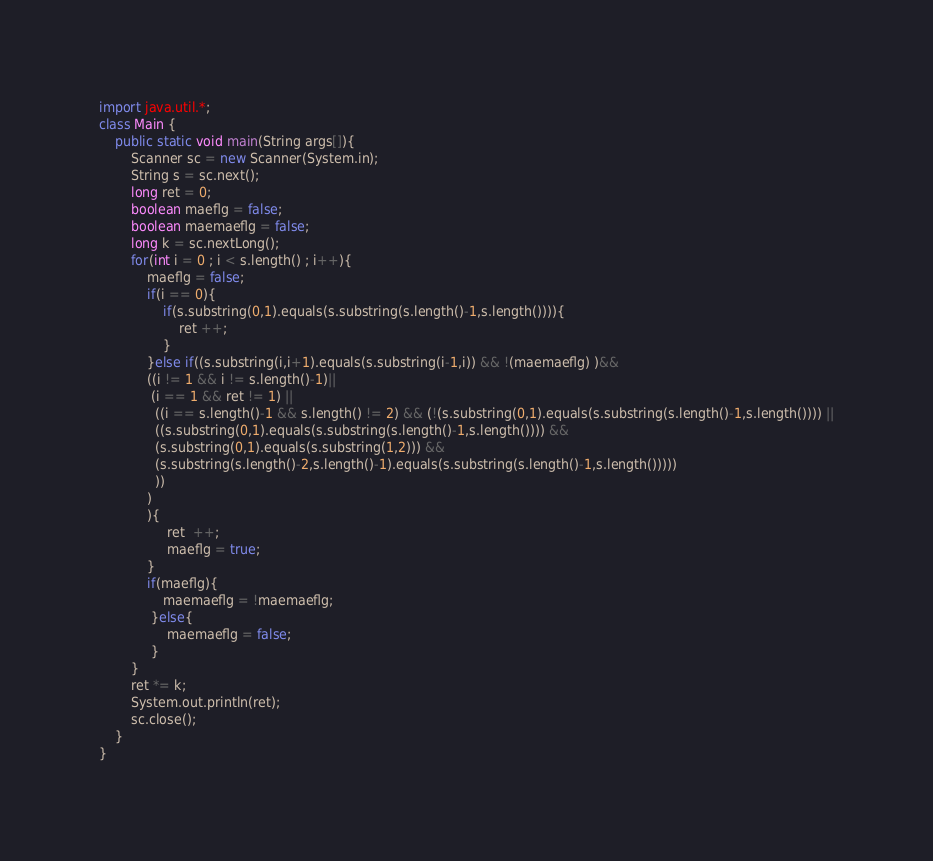Convert code to text. <code><loc_0><loc_0><loc_500><loc_500><_Java_>import java.util.*;
class Main {
    public static void main(String args[]){
        Scanner sc = new Scanner(System.in);
        String s = sc.next();
        long ret = 0;
        boolean maeflg = false; 
        boolean maemaeflg = false;
        long k = sc.nextLong();
        for(int i = 0 ; i < s.length() ; i++){
            maeflg = false;
            if(i == 0){
                if(s.substring(0,1).equals(s.substring(s.length()-1,s.length()))){
                    ret ++;
                }
            }else if((s.substring(i,i+1).equals(s.substring(i-1,i)) && !(maemaeflg) )&&
            ((i != 1 && i != s.length()-1)||
             (i == 1 && ret != 1) ||
              ((i == s.length()-1 && s.length() != 2) && (!(s.substring(0,1).equals(s.substring(s.length()-1,s.length()))) ||
              ((s.substring(0,1).equals(s.substring(s.length()-1,s.length()))) && 
              (s.substring(0,1).equals(s.substring(1,2))) &&
              (s.substring(s.length()-2,s.length()-1).equals(s.substring(s.length()-1,s.length()))))
              ))
            )
            ){
                 ret  ++;
                 maeflg = true;
            }
            if(maeflg){
                maemaeflg = !maemaeflg;
             }else{
                 maemaeflg = false;
             }
        }
        ret *= k; 
        System.out.println(ret);
        sc.close();
    }
}
</code> 